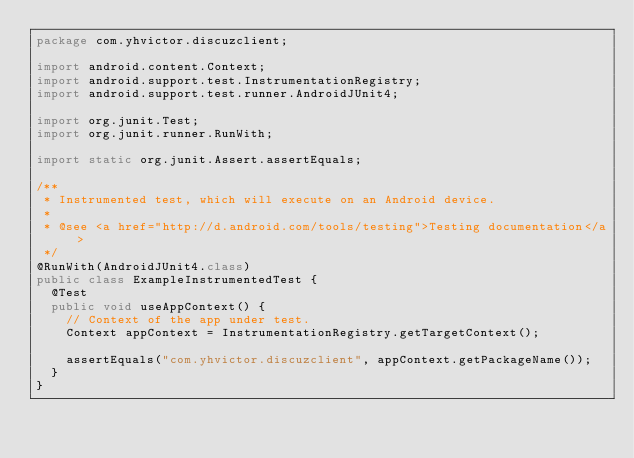<code> <loc_0><loc_0><loc_500><loc_500><_Java_>package com.yhvictor.discuzclient;

import android.content.Context;
import android.support.test.InstrumentationRegistry;
import android.support.test.runner.AndroidJUnit4;

import org.junit.Test;
import org.junit.runner.RunWith;

import static org.junit.Assert.assertEquals;

/**
 * Instrumented test, which will execute on an Android device.
 *
 * @see <a href="http://d.android.com/tools/testing">Testing documentation</a>
 */
@RunWith(AndroidJUnit4.class)
public class ExampleInstrumentedTest {
  @Test
  public void useAppContext() {
    // Context of the app under test.
    Context appContext = InstrumentationRegistry.getTargetContext();

    assertEquals("com.yhvictor.discuzclient", appContext.getPackageName());
  }
}
</code> 